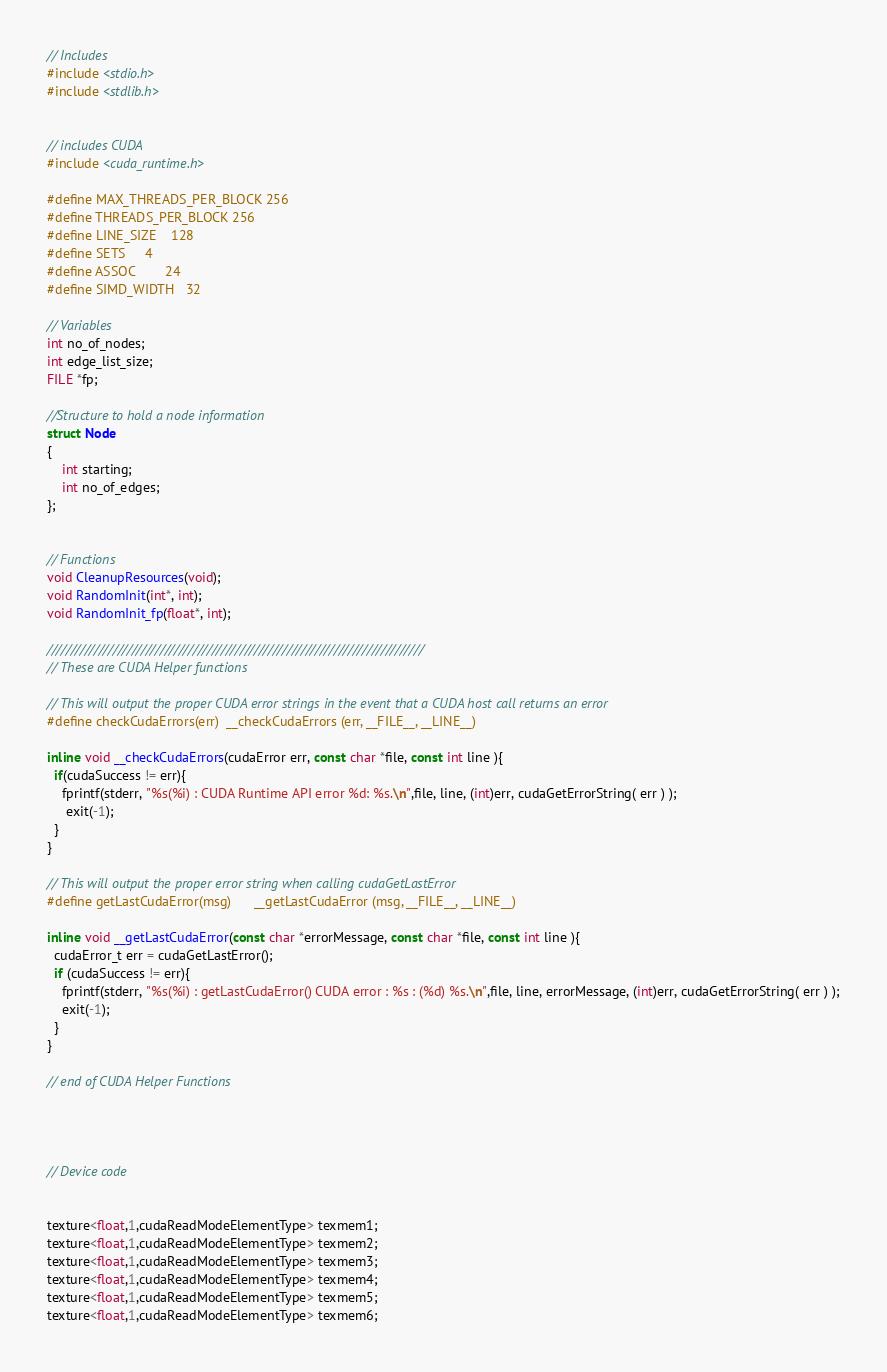Convert code to text. <code><loc_0><loc_0><loc_500><loc_500><_Cuda_>// Includes
#include <stdio.h>
#include <stdlib.h>


// includes CUDA
#include <cuda_runtime.h>

#define MAX_THREADS_PER_BLOCK 256
#define THREADS_PER_BLOCK 256
#define LINE_SIZE 	128
#define SETS		4
#define ASSOC		24
#define SIMD_WIDTH	32

// Variables
int no_of_nodes;
int edge_list_size;
FILE *fp;

//Structure to hold a node information
struct Node
{
	int starting;
	int no_of_edges;
};


// Functions
void CleanupResources(void);
void RandomInit(int*, int);
void RandomInit_fp(float*, int);

////////////////////////////////////////////////////////////////////////////////
// These are CUDA Helper functions

// This will output the proper CUDA error strings in the event that a CUDA host call returns an error
#define checkCudaErrors(err)  __checkCudaErrors (err, __FILE__, __LINE__)

inline void __checkCudaErrors(cudaError err, const char *file, const int line ){
  if(cudaSuccess != err){
	fprintf(stderr, "%s(%i) : CUDA Runtime API error %d: %s.\n",file, line, (int)err, cudaGetErrorString( err ) );
	 exit(-1);
  }
}

// This will output the proper error string when calling cudaGetLastError
#define getLastCudaError(msg)      __getLastCudaError (msg, __FILE__, __LINE__)

inline void __getLastCudaError(const char *errorMessage, const char *file, const int line ){
  cudaError_t err = cudaGetLastError();
  if (cudaSuccess != err){
	fprintf(stderr, "%s(%i) : getLastCudaError() CUDA error : %s : (%d) %s.\n",file, line, errorMessage, (int)err, cudaGetErrorString( err ) );
	exit(-1);
  }
}

// end of CUDA Helper Functions




// Device code


texture<float,1,cudaReadModeElementType> texmem1;
texture<float,1,cudaReadModeElementType> texmem2;
texture<float,1,cudaReadModeElementType> texmem3;
texture<float,1,cudaReadModeElementType> texmem4;
texture<float,1,cudaReadModeElementType> texmem5;
texture<float,1,cudaReadModeElementType> texmem6;</code> 